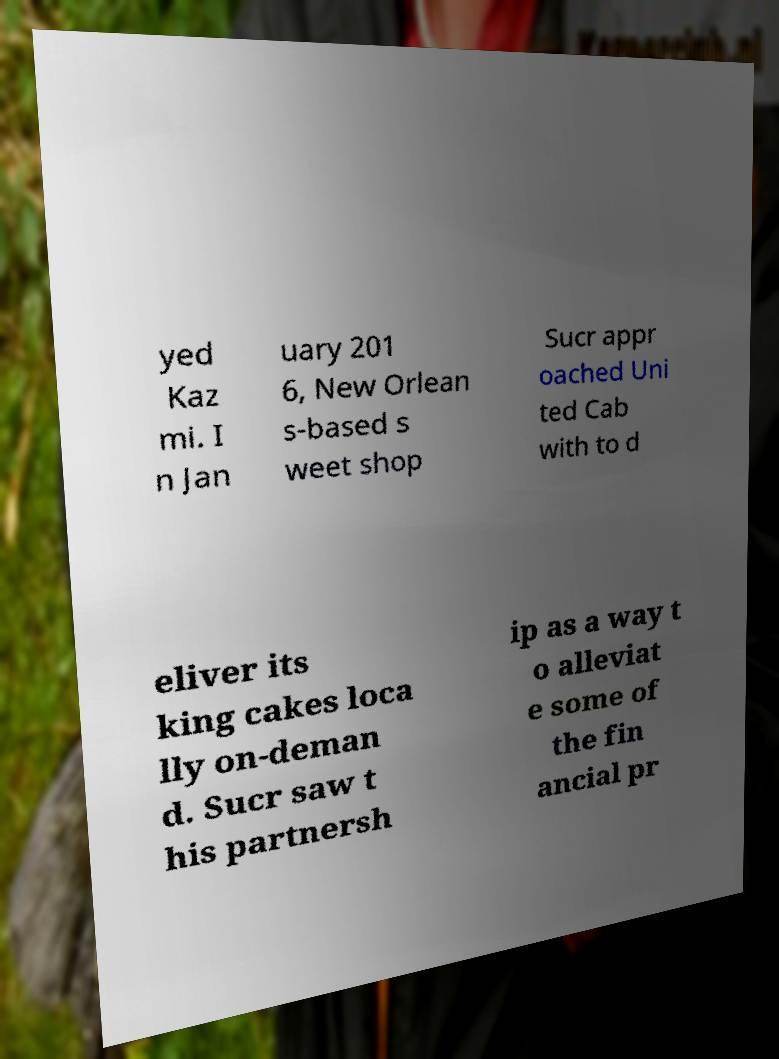Can you read and provide the text displayed in the image?This photo seems to have some interesting text. Can you extract and type it out for me? yed Kaz mi. I n Jan uary 201 6, New Orlean s-based s weet shop Sucr appr oached Uni ted Cab with to d eliver its king cakes loca lly on-deman d. Sucr saw t his partnersh ip as a way t o alleviat e some of the fin ancial pr 